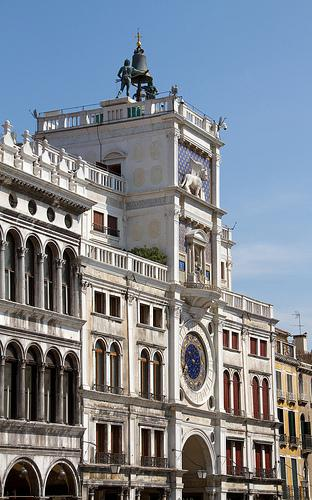Question: how many birds on the sky?
Choices:
A. 1.
B. 0.
C. 2.
D. 3.
Answer with the letter. Answer: B Question: what time of the day it is?
Choices:
A. Morning.
B. Noon.
C. Night.
D. Dawn.
Answer with the letter. Answer: B Question: what is the color of the sky?
Choices:
A. Grey.
B. Black.
C. Blue.
D. White.
Answer with the letter. Answer: C Question: when was the building completed?
Choices:
A. Last month.
B. 2000.
C. Years ago.
D. 1850's.
Answer with the letter. Answer: C Question: who under the clock?
Choices:
A. Passenger.
B. Date.
C. No one.
D. Commuter.
Answer with the letter. Answer: C 